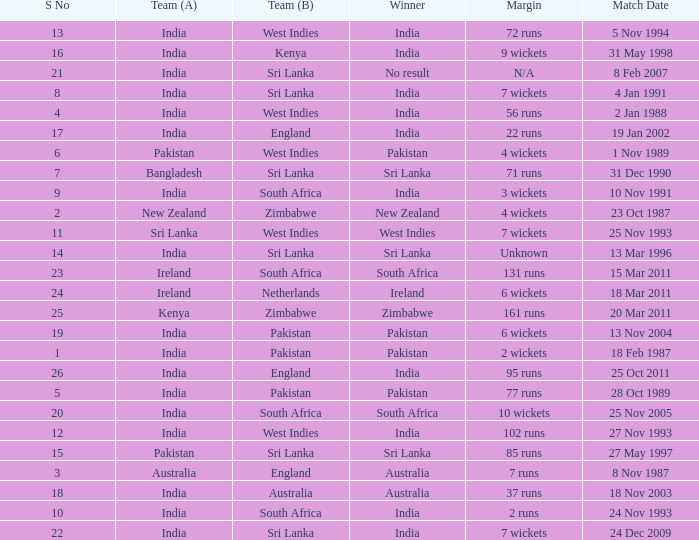How many games were won by a margin of 131 runs? 1.0. 